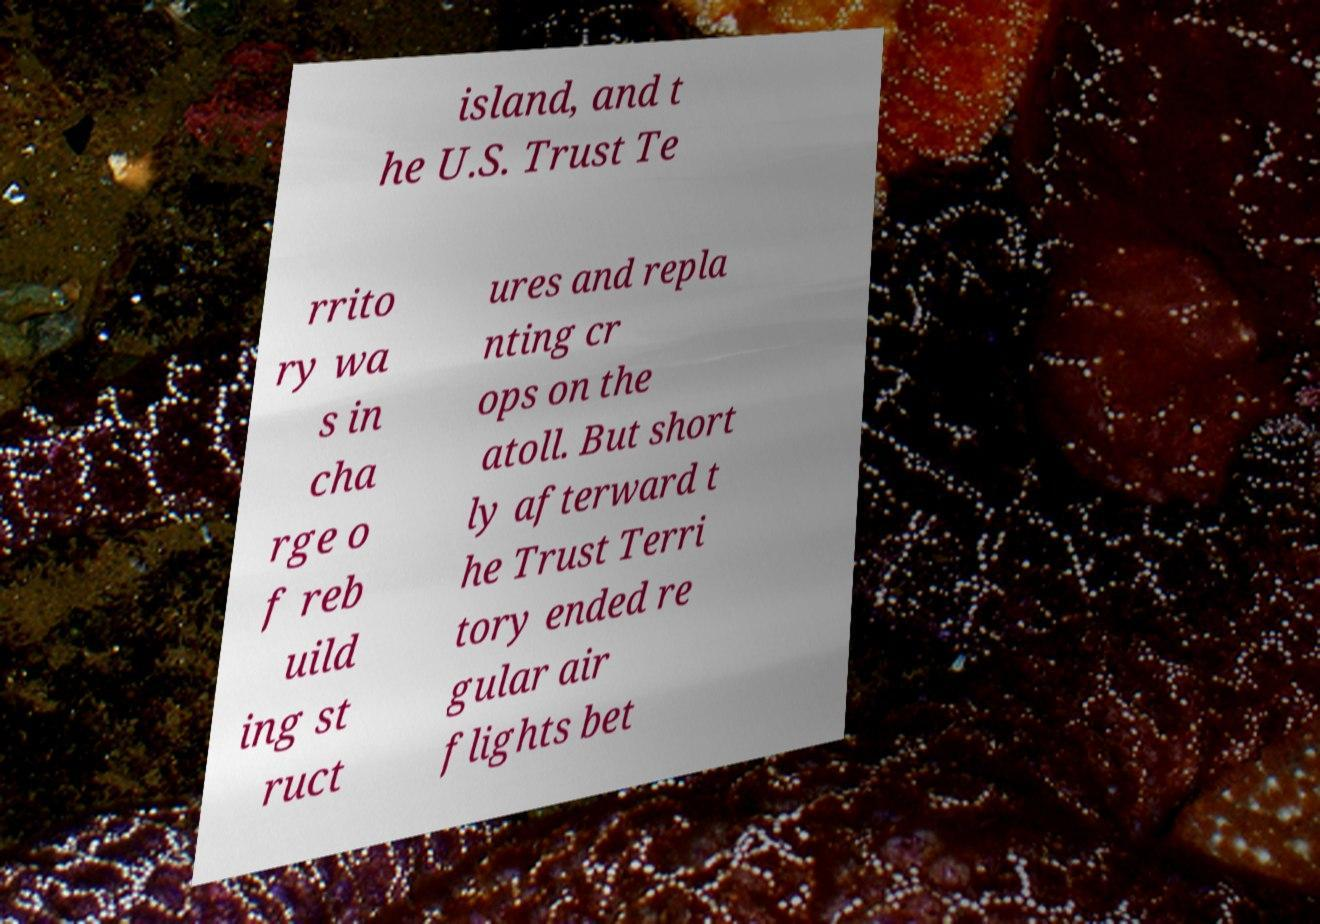Can you accurately transcribe the text from the provided image for me? island, and t he U.S. Trust Te rrito ry wa s in cha rge o f reb uild ing st ruct ures and repla nting cr ops on the atoll. But short ly afterward t he Trust Terri tory ended re gular air flights bet 